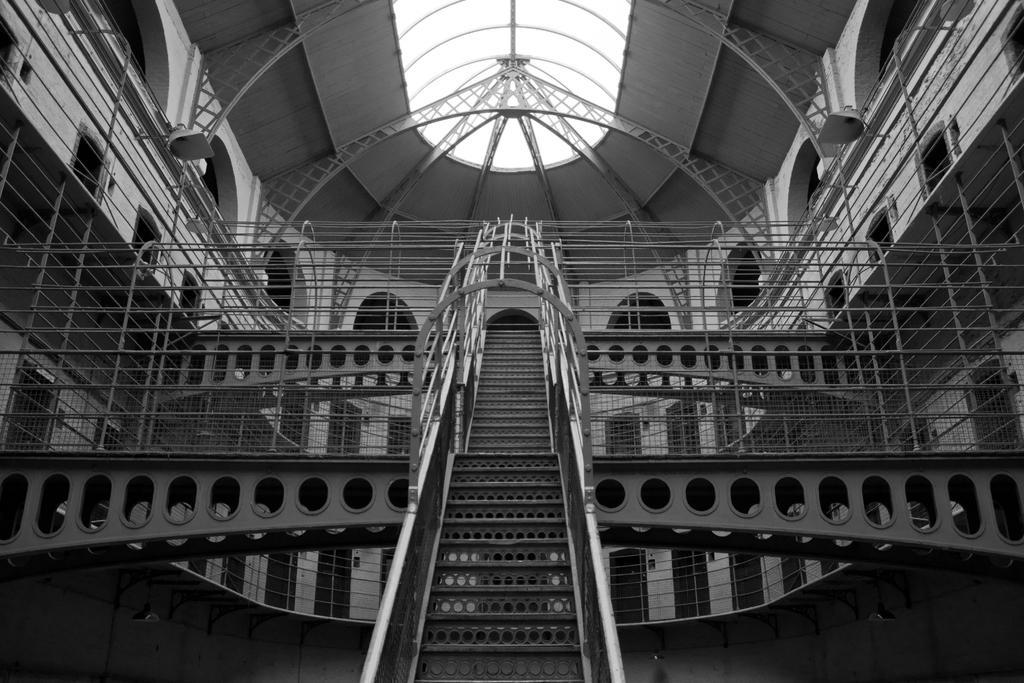Describe this image in one or two sentences. In the middle of this image, there are steps having a fence on both sides. Behind these steps, there are two bridges having fences. In the background, there is a building having a roof, doors and pillars. 